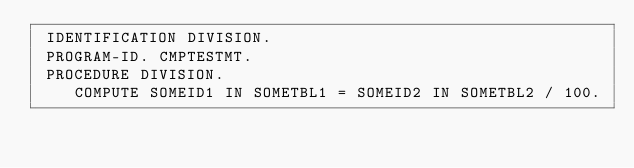<code> <loc_0><loc_0><loc_500><loc_500><_COBOL_> IDENTIFICATION DIVISION.
 PROGRAM-ID. CMPTESTMT.
 PROCEDURE DIVISION.
    COMPUTE SOMEID1 IN SOMETBL1 = SOMEID2 IN SOMETBL2 / 100.</code> 